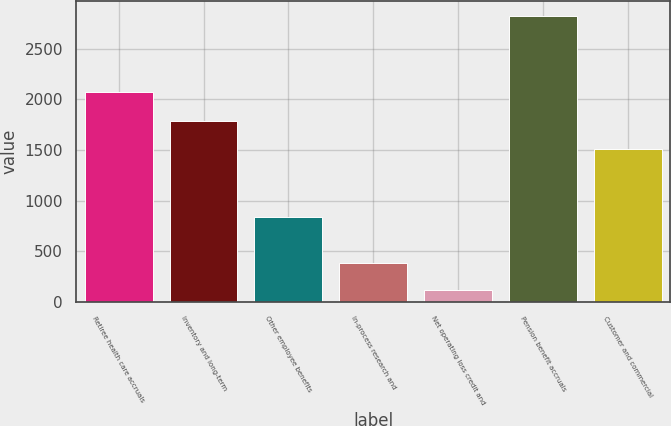<chart> <loc_0><loc_0><loc_500><loc_500><bar_chart><fcel>Retiree health care accruals<fcel>Inventory and long-term<fcel>Other employee benefits<fcel>In-process research and<fcel>Net operating loss credit and<fcel>Pension benefit accruals<fcel>Customer and commercial<nl><fcel>2073<fcel>1783.8<fcel>842<fcel>388.8<fcel>118<fcel>2826<fcel>1513<nl></chart> 